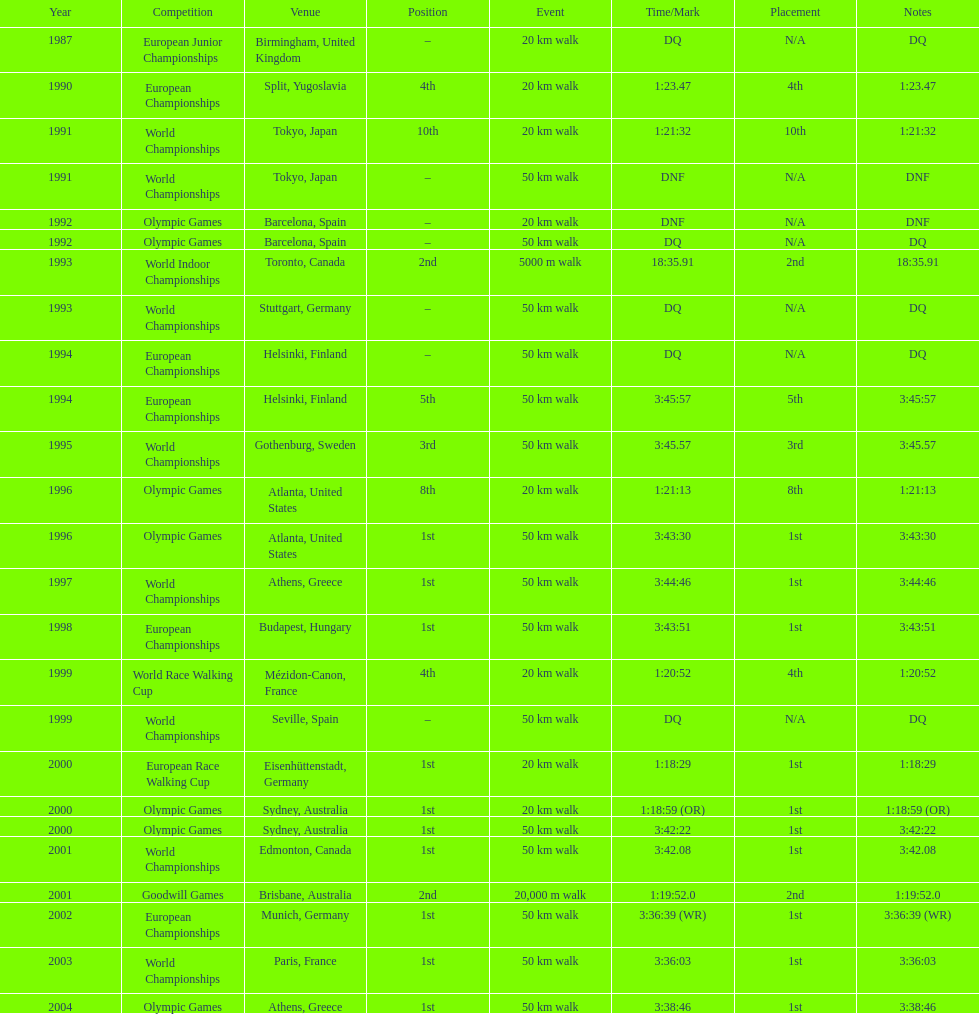Which place is cited the most? Athens, Greece. Write the full table. {'header': ['Year', 'Competition', 'Venue', 'Position', 'Event', 'Time/Mark', 'Placement', 'Notes'], 'rows': [['1987', 'European Junior Championships', 'Birmingham, United Kingdom', '–', '20\xa0km walk', 'DQ', 'N/A', 'DQ'], ['1990', 'European Championships', 'Split, Yugoslavia', '4th', '20\xa0km walk', '1:23.47', '4th', '1:23.47'], ['1991', 'World Championships', 'Tokyo, Japan', '10th', '20\xa0km walk', '1:21:32', '10th', '1:21:32'], ['1991', 'World Championships', 'Tokyo, Japan', '–', '50\xa0km walk', 'DNF', 'N/A', 'DNF'], ['1992', 'Olympic Games', 'Barcelona, Spain', '–', '20\xa0km walk', 'DNF', 'N/A', 'DNF'], ['1992', 'Olympic Games', 'Barcelona, Spain', '–', '50\xa0km walk', 'DQ', 'N/A', 'DQ'], ['1993', 'World Indoor Championships', 'Toronto, Canada', '2nd', '5000 m walk', '18:35.91', '2nd', '18:35.91'], ['1993', 'World Championships', 'Stuttgart, Germany', '–', '50\xa0km walk', 'DQ', 'N/A', 'DQ'], ['1994', 'European Championships', 'Helsinki, Finland', '–', '50\xa0km walk', 'DQ', 'N/A', 'DQ'], ['1994', 'European Championships', 'Helsinki, Finland', '5th', '50\xa0km walk', '3:45:57', '5th', '3:45:57'], ['1995', 'World Championships', 'Gothenburg, Sweden', '3rd', '50\xa0km walk', '3:45.57', '3rd', '3:45.57'], ['1996', 'Olympic Games', 'Atlanta, United States', '8th', '20\xa0km walk', '1:21:13', '8th', '1:21:13'], ['1996', 'Olympic Games', 'Atlanta, United States', '1st', '50\xa0km walk', '3:43:30', '1st', '3:43:30'], ['1997', 'World Championships', 'Athens, Greece', '1st', '50\xa0km walk', '3:44:46', '1st', '3:44:46'], ['1998', 'European Championships', 'Budapest, Hungary', '1st', '50\xa0km walk', '3:43:51', '1st', '3:43:51'], ['1999', 'World Race Walking Cup', 'Mézidon-Canon, France', '4th', '20\xa0km walk', '1:20:52', '4th', '1:20:52'], ['1999', 'World Championships', 'Seville, Spain', '–', '50\xa0km walk', 'DQ', 'N/A', 'DQ'], ['2000', 'European Race Walking Cup', 'Eisenhüttenstadt, Germany', '1st', '20\xa0km walk', '1:18:29', '1st', '1:18:29'], ['2000', 'Olympic Games', 'Sydney, Australia', '1st', '20\xa0km walk', '1:18:59 (OR)', '1st', '1:18:59 (OR)'], ['2000', 'Olympic Games', 'Sydney, Australia', '1st', '50\xa0km walk', '3:42:22', '1st', '3:42:22'], ['2001', 'World Championships', 'Edmonton, Canada', '1st', '50\xa0km walk', '3:42.08', '1st', '3:42.08'], ['2001', 'Goodwill Games', 'Brisbane, Australia', '2nd', '20,000 m walk', '1:19:52.0', '2nd', '1:19:52.0'], ['2002', 'European Championships', 'Munich, Germany', '1st', '50\xa0km walk', '3:36:39 (WR)', '1st', '3:36:39 (WR)'], ['2003', 'World Championships', 'Paris, France', '1st', '50\xa0km walk', '3:36:03', '1st', '3:36:03'], ['2004', 'Olympic Games', 'Athens, Greece', '1st', '50\xa0km walk', '3:38:46', '1st', '3:38:46']]} 